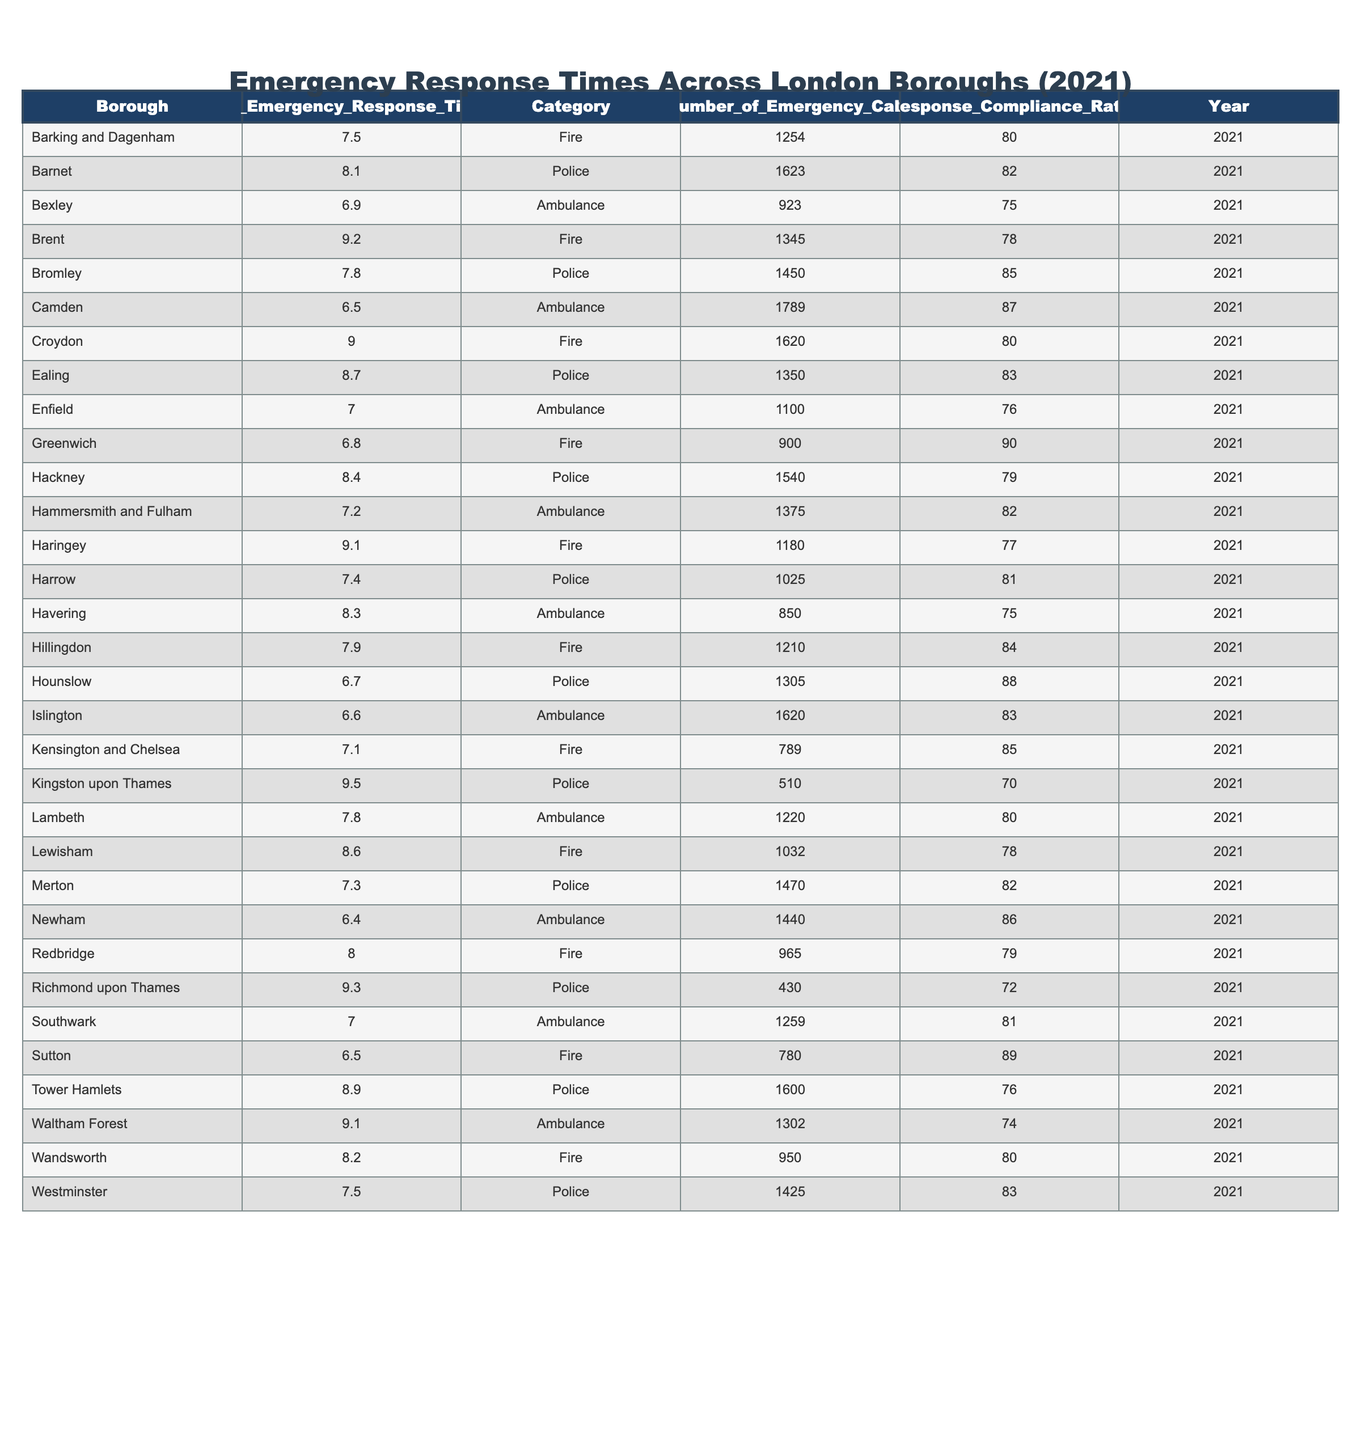What is the average emergency response time for the borough of Hackney? According to the table, Hackney has an average emergency response time of 8.4 minutes, as stated in the relevant row.
Answer: 8.4 Which borough has the fastest average emergency response time for ambulances? The table shows that Newham has the fastest average emergency response time for ambulances at 6.4 minutes.
Answer: 6.4 How many emergency calls did Bromley receive in 2021? From the table, Bromley received 1450 emergency calls, as indicated in the corresponding row.
Answer: 1450 Which category had the highest average emergency response time among all boroughs? Looking at the table, the police category had the highest average emergency response time of 9.5 minutes in Kingston upon Thames.
Answer: 9.5 Is it true that Barking and Dagenham has a better response compliance rate than Greenwich? The table indicates that Barking and Dagenham has a response compliance rate of 80%, while Greenwich has a rate of 90%. Thus, Barking and Dagenham does not have a better compliance rate than Greenwich.
Answer: No What is the total number of emergency calls for all Fire categories in the boroughs listed? To calculate this, we sum the number of emergency calls for each borough under the Fire category: 1254 (Barking and Dagenham) + 1345 (Brent) + 1620 (Croydon) + 900 (Greenwich) + 1180 (Haringey) + 1210 (Hillingdon) + 965 (Redbridge) + 9.1 (Lewisham) + 950 (Wandsworth). Total = 1254 + 1345 + 1620 + 900 + 1180 + 1210 + 965 = 10194.
Answer: 10194 Which boroughs had an average emergency response time below 8 minutes? By examining the table, we identify that Bexley (6.9 minutes), Camden (6.5 minutes), Hounslow (6.7 minutes), Islington (6.6 minutes), and Newham (6.4 minutes) all have average response times below 8 minutes.
Answer: Bexley, Camden, Hounslow, Islington, Newham What is the difference between the average emergency response times for the ambulance category in Camden and the one in Enfield? The average response time for ambulances in Camden is 6.5 minutes and in Enfield it is 7.0 minutes. The difference is 7.0 - 6.5 = 0.5 minutes.
Answer: 0.5 